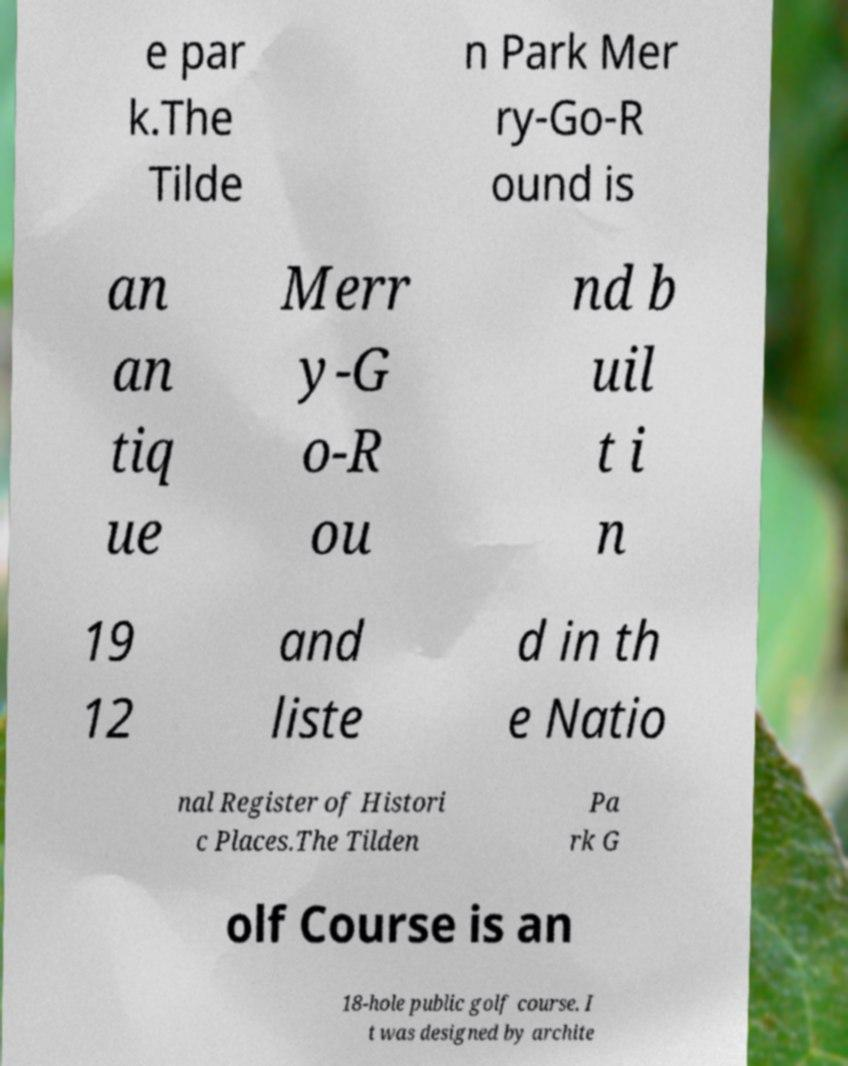Please read and relay the text visible in this image. What does it say? e par k.The Tilde n Park Mer ry-Go-R ound is an an tiq ue Merr y-G o-R ou nd b uil t i n 19 12 and liste d in th e Natio nal Register of Histori c Places.The Tilden Pa rk G olf Course is an 18-hole public golf course. I t was designed by archite 